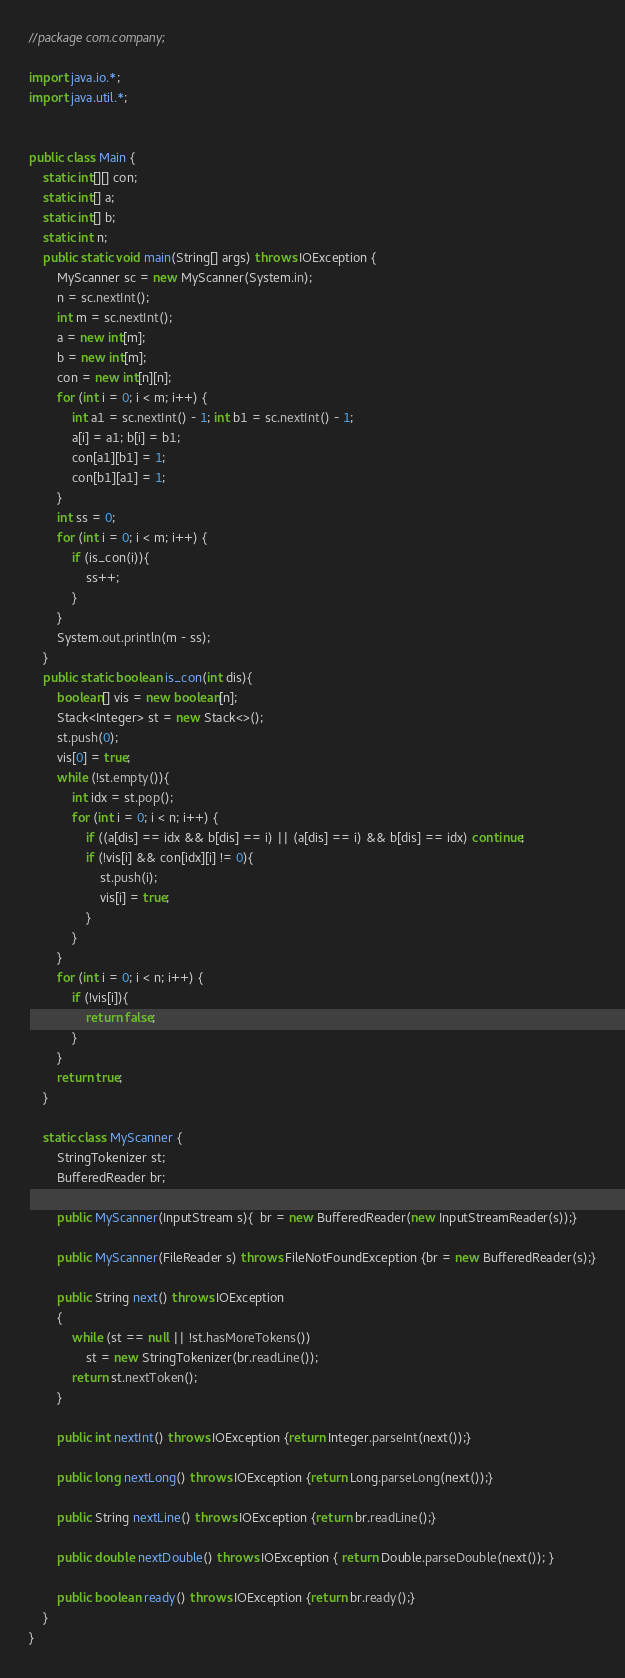Convert code to text. <code><loc_0><loc_0><loc_500><loc_500><_Java_>//package com.company;

import java.io.*;
import java.util.*;


public class Main {
    static int[][] con;
    static int[] a;
    static int[] b;
    static int n;
    public static void main(String[] args) throws IOException {
        MyScanner sc = new MyScanner(System.in);
        n = sc.nextInt();
        int m = sc.nextInt();
        a = new int[m];
        b = new int[m];
        con = new int[n][n];
        for (int i = 0; i < m; i++) {
            int a1 = sc.nextInt() - 1; int b1 = sc.nextInt() - 1;
            a[i] = a1; b[i] = b1;
            con[a1][b1] = 1;
            con[b1][a1] = 1;
        }
        int ss = 0;
        for (int i = 0; i < m; i++) {
            if (is_con(i)){
                ss++;
            }
        }
        System.out.println(m - ss);
    }
    public static boolean is_con(int dis){
        boolean[] vis = new boolean[n];
        Stack<Integer> st = new Stack<>();
        st.push(0);
        vis[0] = true;
        while (!st.empty()){
            int idx = st.pop();
            for (int i = 0; i < n; i++) {
                if ((a[dis] == idx && b[dis] == i) || (a[dis] == i) && b[dis] == idx) continue;
                if (!vis[i] && con[idx][i] != 0){
                    st.push(i);
                    vis[i] = true;
                }
            }
        }
        for (int i = 0; i < n; i++) {
            if (!vis[i]){
                return false;
            }
        }
        return true;
    }

    static class MyScanner {
        StringTokenizer st;
        BufferedReader br;

        public MyScanner(InputStream s){  br = new BufferedReader(new InputStreamReader(s));}

        public MyScanner(FileReader s) throws FileNotFoundException {br = new BufferedReader(s);}

        public String next() throws IOException
        {
            while (st == null || !st.hasMoreTokens())
                st = new StringTokenizer(br.readLine());
            return st.nextToken();
        }

        public int nextInt() throws IOException {return Integer.parseInt(next());}

        public long nextLong() throws IOException {return Long.parseLong(next());}

        public String nextLine() throws IOException {return br.readLine();}

        public double nextDouble() throws IOException { return Double.parseDouble(next()); }

        public boolean ready() throws IOException {return br.ready();}
    }
}</code> 